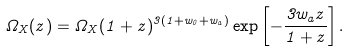<formula> <loc_0><loc_0><loc_500><loc_500>\Omega _ { X } ( z ) = \Omega _ { X } ( 1 + z ) ^ { 3 ( 1 + w _ { 0 } + w _ { a } ) } \exp \left [ - \frac { 3 w _ { a } z } { 1 + z } \right ] .</formula> 